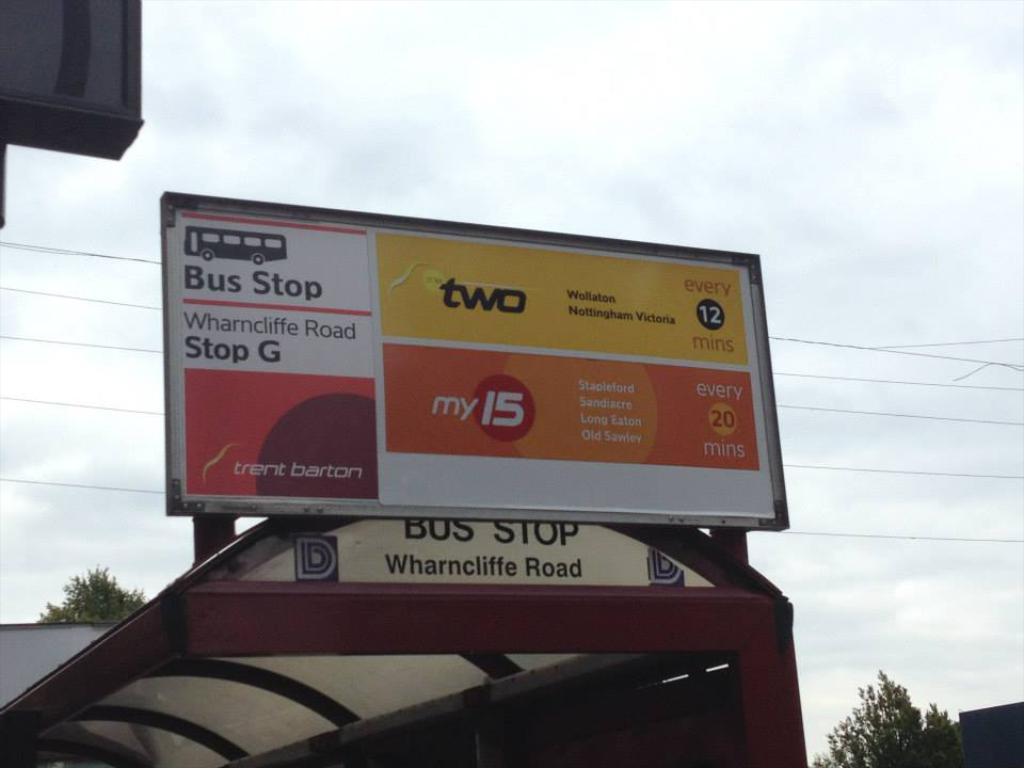<image>
Present a compact description of the photo's key features. Bus stop G is on Wharncliffe Road and runs every 12 minutes. 